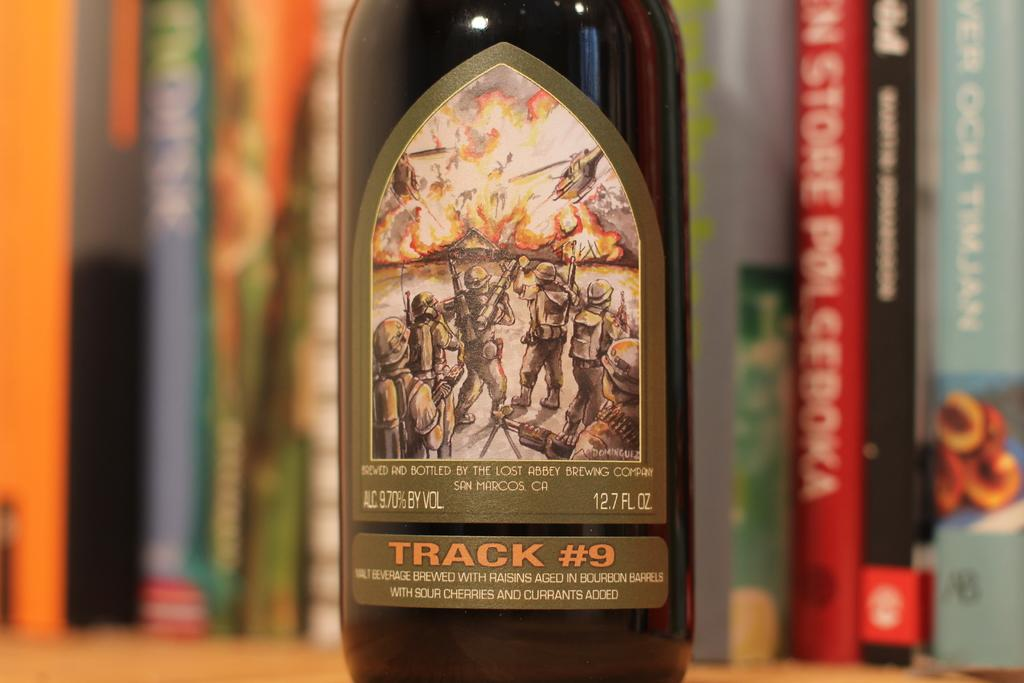<image>
Offer a succinct explanation of the picture presented. A wine bottle with soldiers on it and is 12.7 Fl oz. 